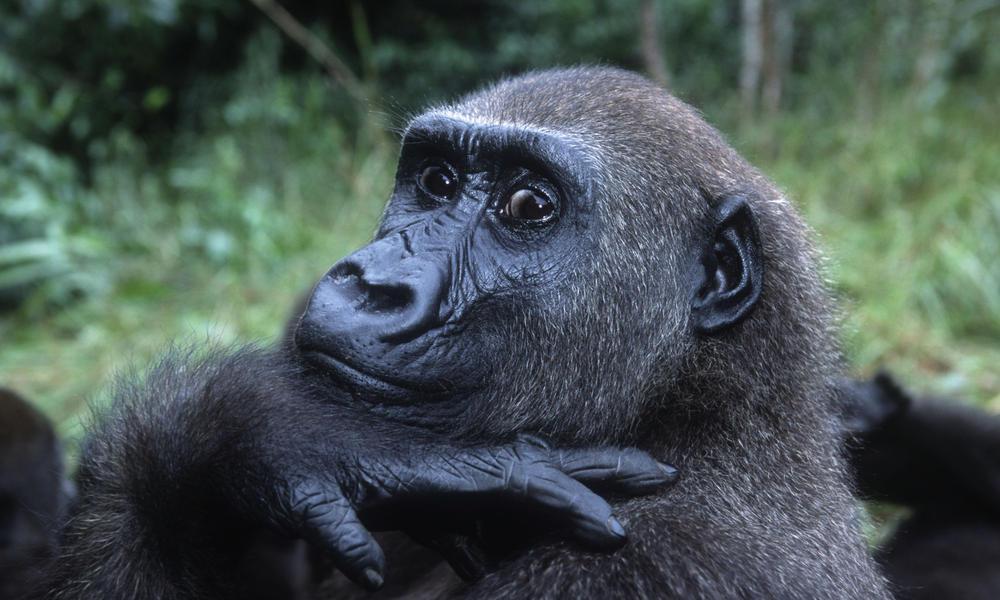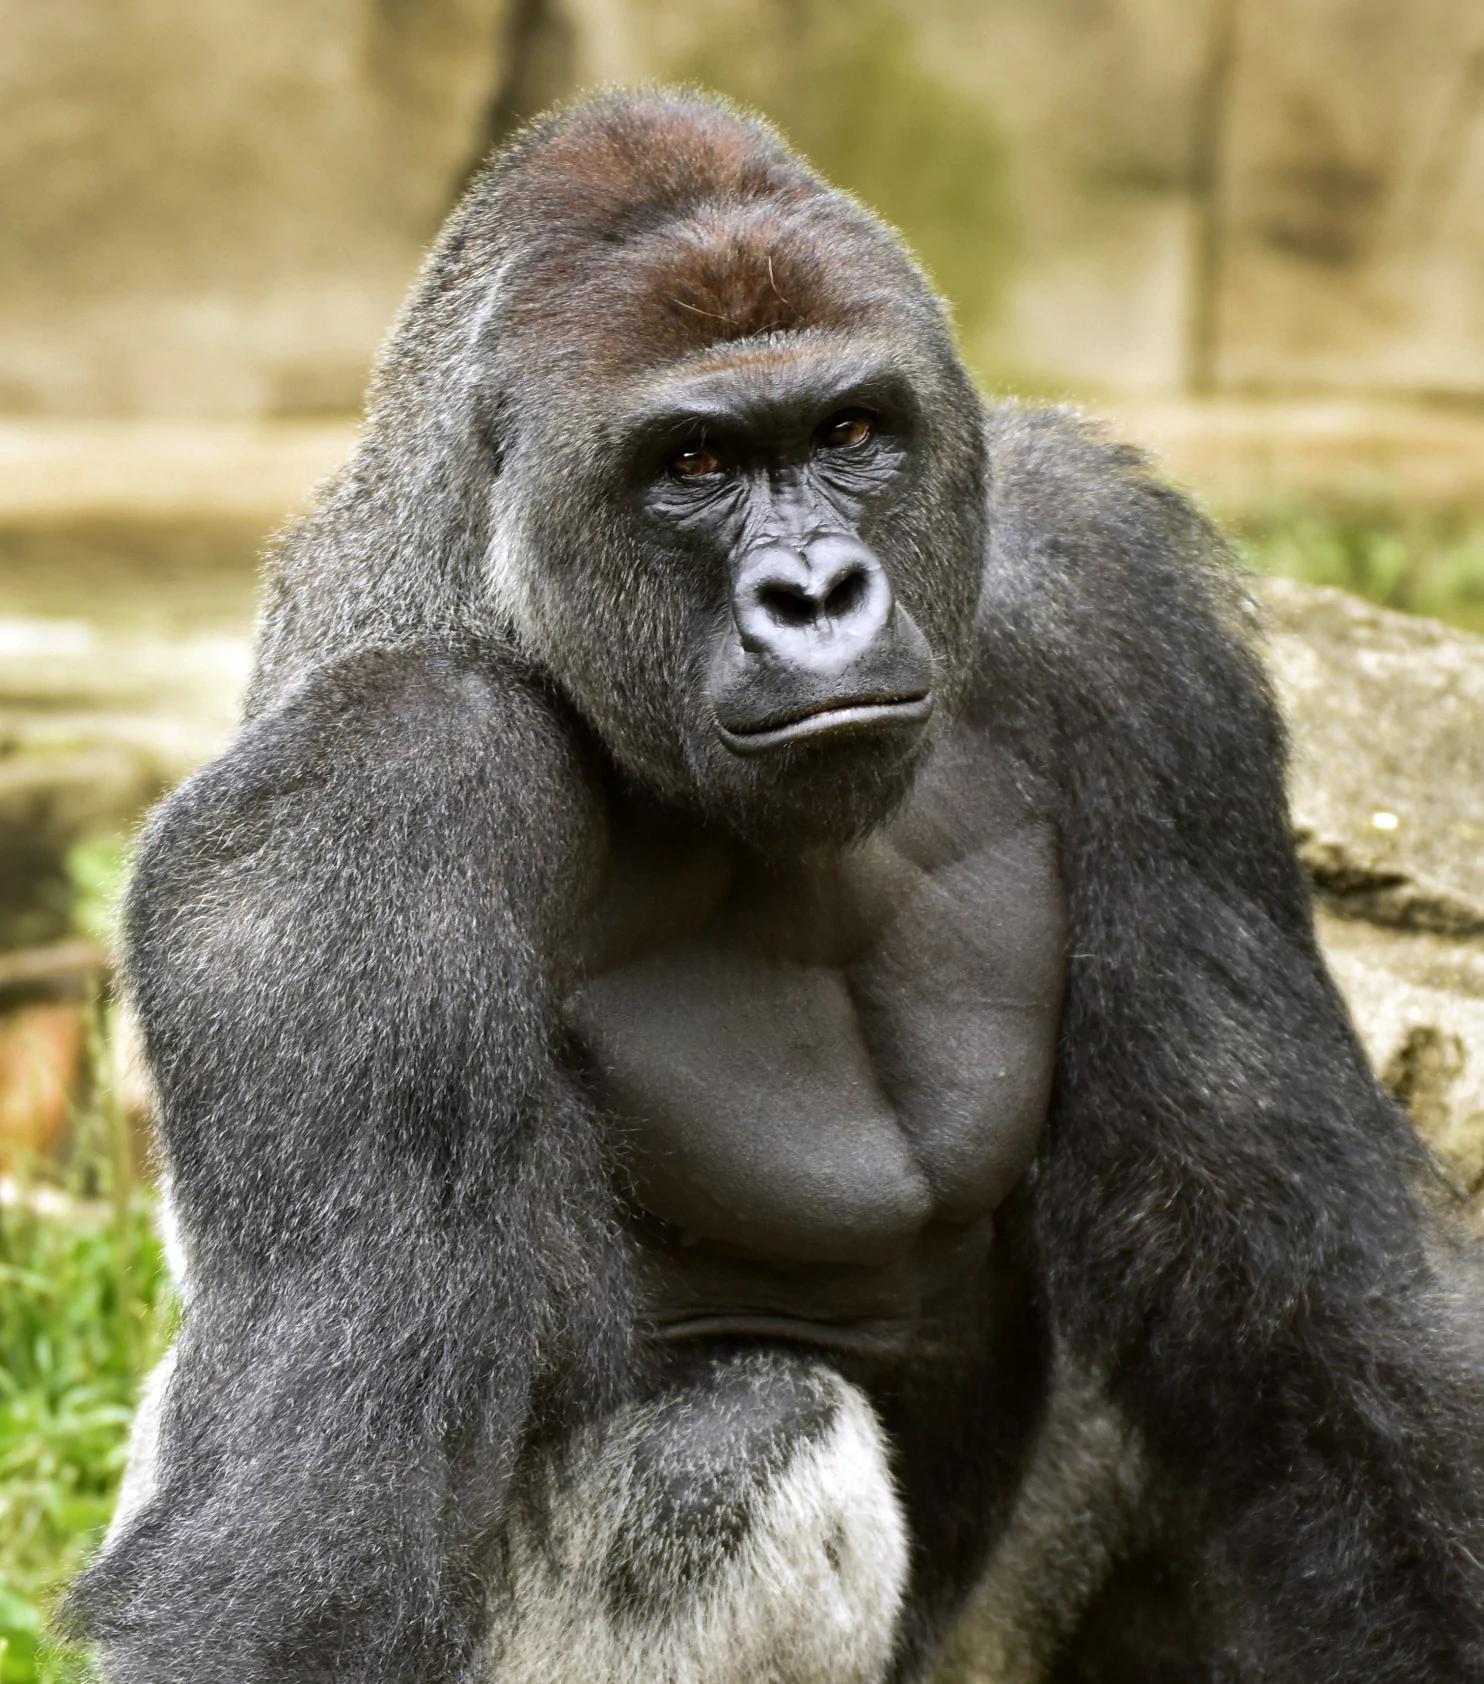The first image is the image on the left, the second image is the image on the right. Given the left and right images, does the statement "A baby gorilla is with at least one adult in one image." hold true? Answer yes or no. No. 